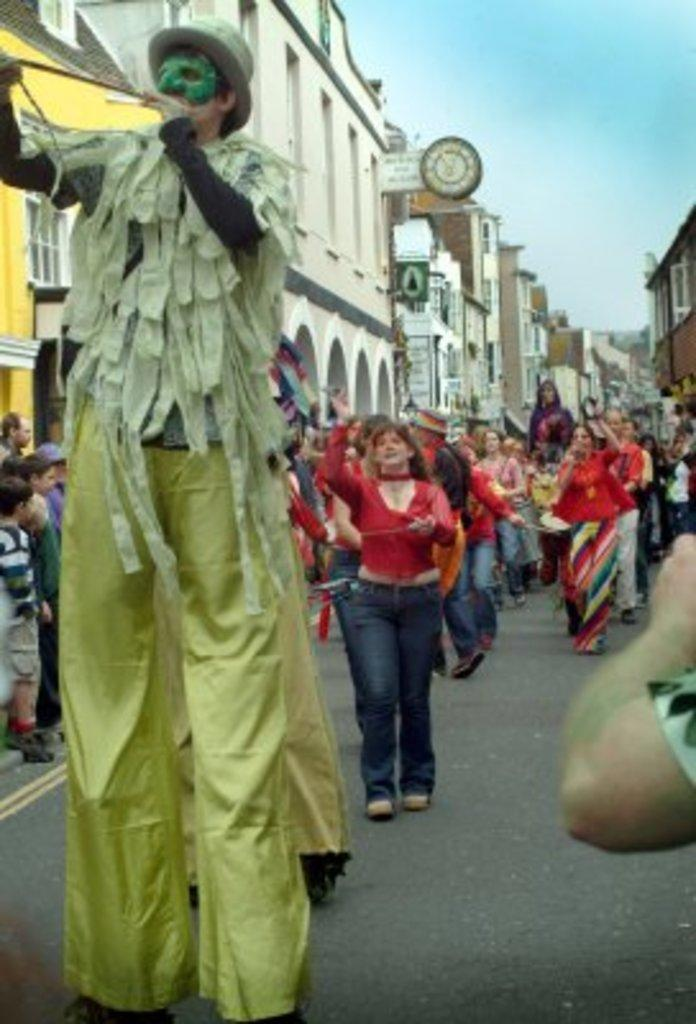Where was the image taken? The image was clicked outside. What can be seen in the middle of the image? There are buildings and people in the middle of the image. Can you describe the people in the image? There is a tall person in the middle of the image. What is visible at the top of the image? The sky is visible at the top of the image. What part of the plant is growing in the image? There is no plant present in the image; it features buildings, people, and a tall person outside. 